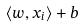<formula> <loc_0><loc_0><loc_500><loc_500>\langle w , x _ { i } \rangle + b</formula> 